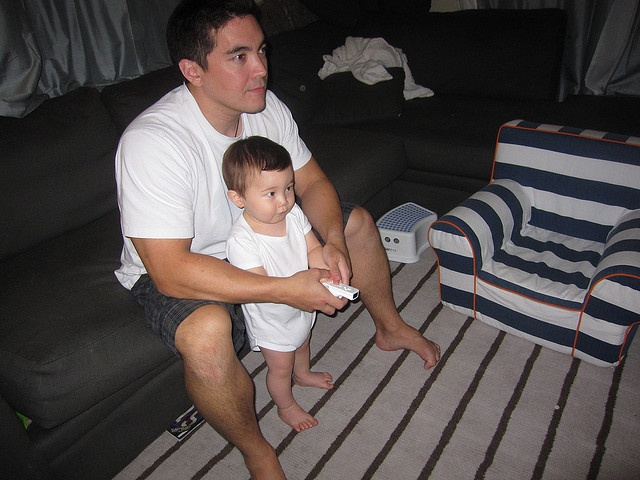Describe the objects in this image and their specific colors. I can see couch in black, gray, darkgray, and maroon tones, people in black, brown, and lightgray tones, chair in black, darkgray, and gray tones, people in black, lightgray, tan, and darkgray tones, and remote in black, white, darkgray, pink, and brown tones in this image. 